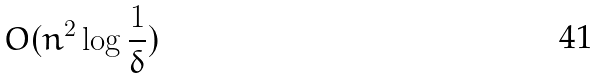Convert formula to latex. <formula><loc_0><loc_0><loc_500><loc_500>O ( n ^ { 2 } \log \frac { 1 } { \delta } )</formula> 